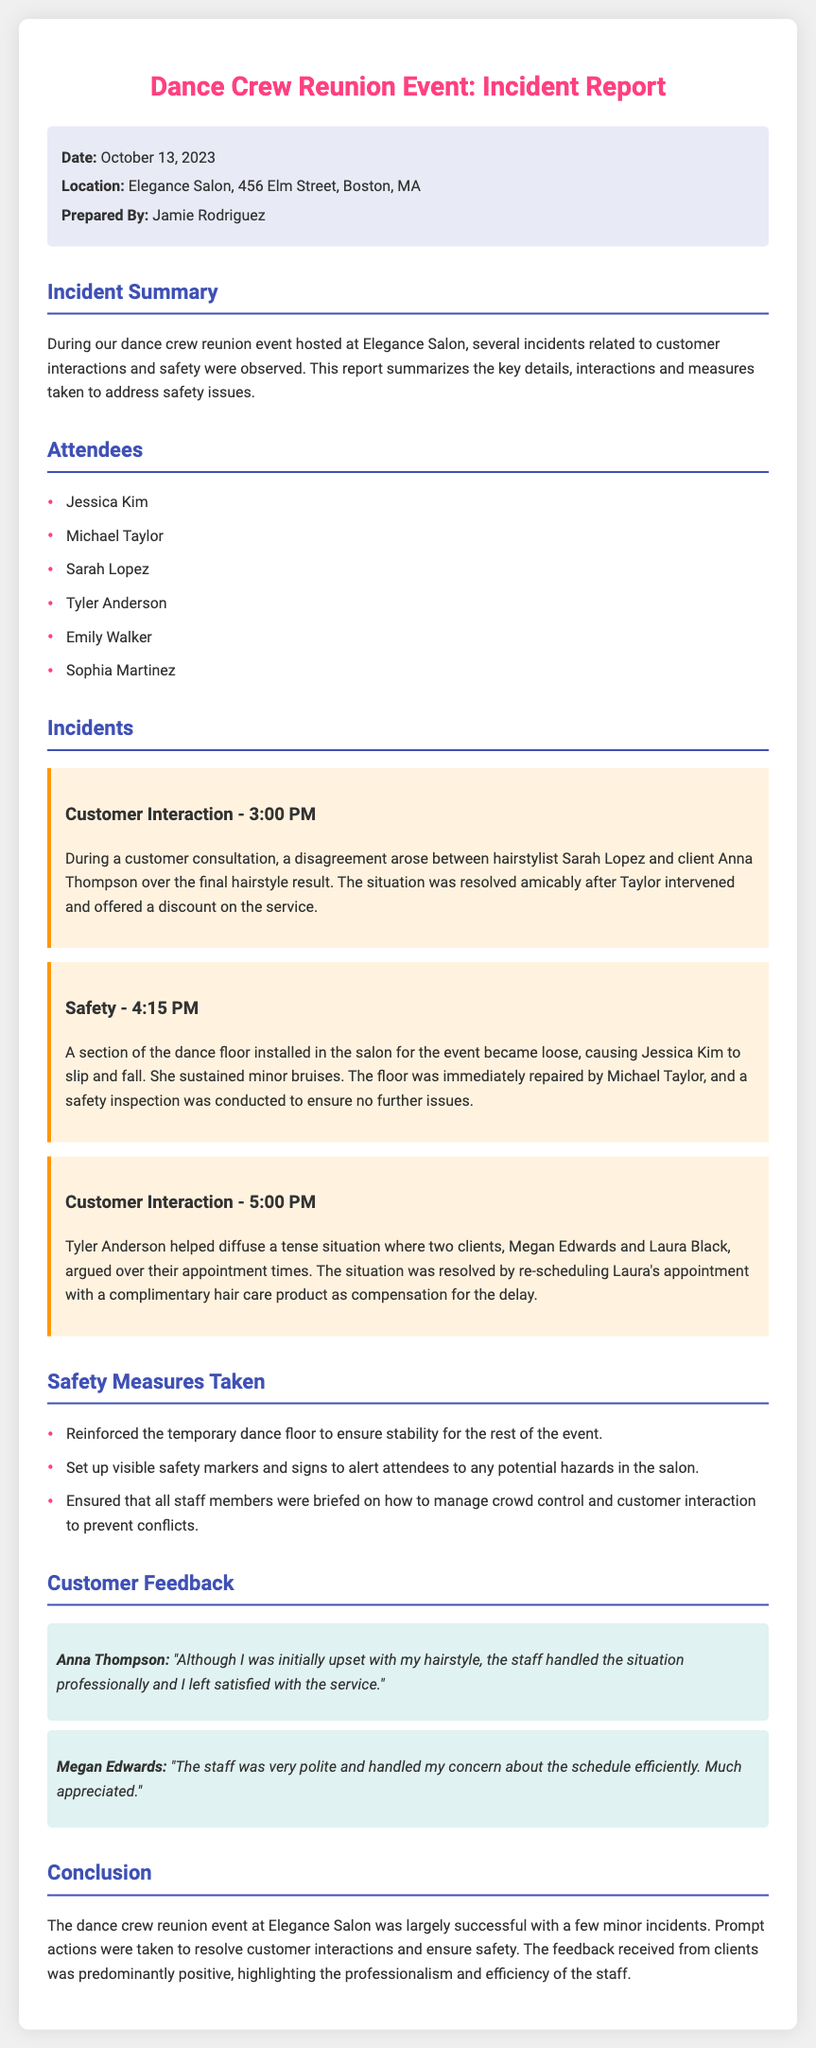what is the date of the event? The date of the event is stated in the report as October 13, 2023.
Answer: October 13, 2023 where was the event held? The report specifies that the event took place at Elegance Salon, located at 456 Elm Street, Boston, MA.
Answer: Elegance Salon, 456 Elm Street, Boston, MA who prepared the incident report? The report indicates that Jamie Rodriguez prepared the incident report.
Answer: Jamie Rodriguez what time did the customer interaction incident occur involving Sarah Lopez? The incident with Sarah Lopez occurred at 3:00 PM as stated in the report.
Answer: 3:00 PM what safety issue was reported at 4:15 PM? The incident report mentions that a part of the dance floor became loose, causing Jessica Kim to slip and fall.
Answer: A section of the dance floor became loose how many attendees were listed? The report lists six attendees who participated in the dance crew reunion event.
Answer: Six what action did Michael Taylor take during the safety incident? The report explains that Michael Taylor repaired the loose floor immediately after the incident occurred.
Answer: Repaired the floor what compensation was offered to Laura Black for her appointment delay? The report states that Laura Black was offered a complimentary hair care product for the delay in her appointment.
Answer: Complimentary hair care product who intervened in the argument between Megan Edwards and Laura Black? Tyler Anderson helped to diffuse the situation between the two clients according to the report.
Answer: Tyler Anderson 